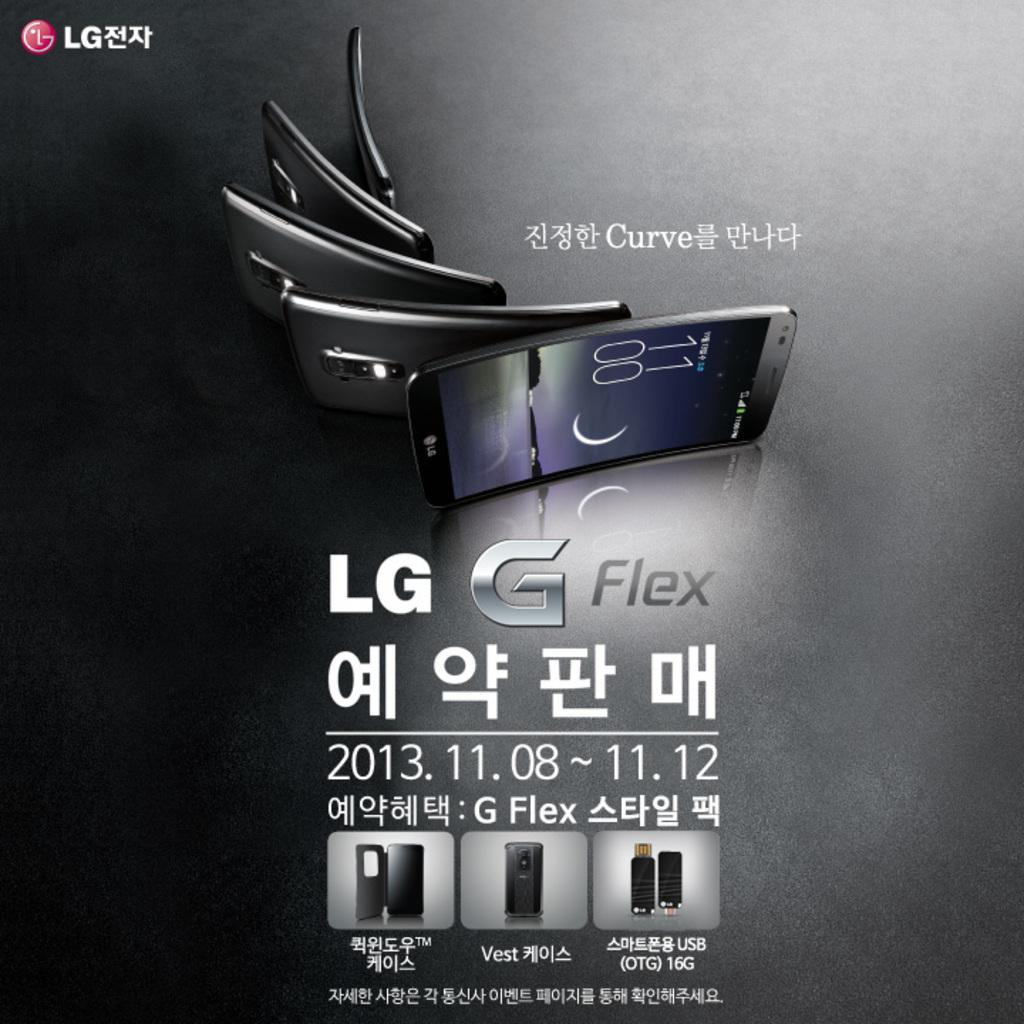Provide a one-sentence caption for the provided image. A advertisement for an LG curve G Flex smartphone with the cellphone displayed as it curves. 